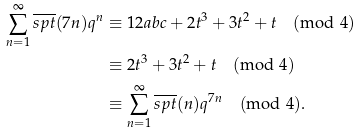<formula> <loc_0><loc_0><loc_500><loc_500>\sum _ { n = 1 } ^ { \infty } \overline { s p t } ( 7 n ) q ^ { n } & \equiv 1 2 a b c + 2 t ^ { 3 } + 3 t ^ { 2 } + t \pmod { 4 } \\ & \equiv 2 t ^ { 3 } + 3 t ^ { 2 } + t \pmod { 4 } \\ & \equiv \sum _ { n = 1 } ^ { \infty } \overline { s p t } ( n ) q ^ { 7 n } \pmod { 4 } \text {.}</formula> 